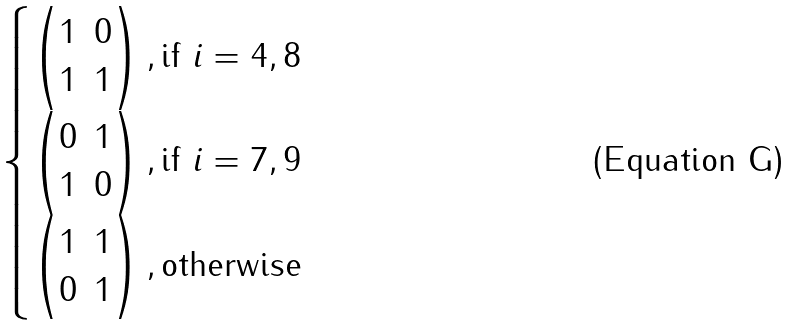Convert formula to latex. <formula><loc_0><loc_0><loc_500><loc_500>\begin{cases} \begin{pmatrix} 1 & 0 \\ 1 & 1 \end{pmatrix} , \text {if } i = 4 , 8 \\ \begin{pmatrix} 0 & 1 \\ 1 & 0 \end{pmatrix} , \text {if } i = 7 , 9 \\ \begin{pmatrix} 1 & 1 \\ 0 & 1 \end{pmatrix} , \text {otherwise} \\ \end{cases}</formula> 